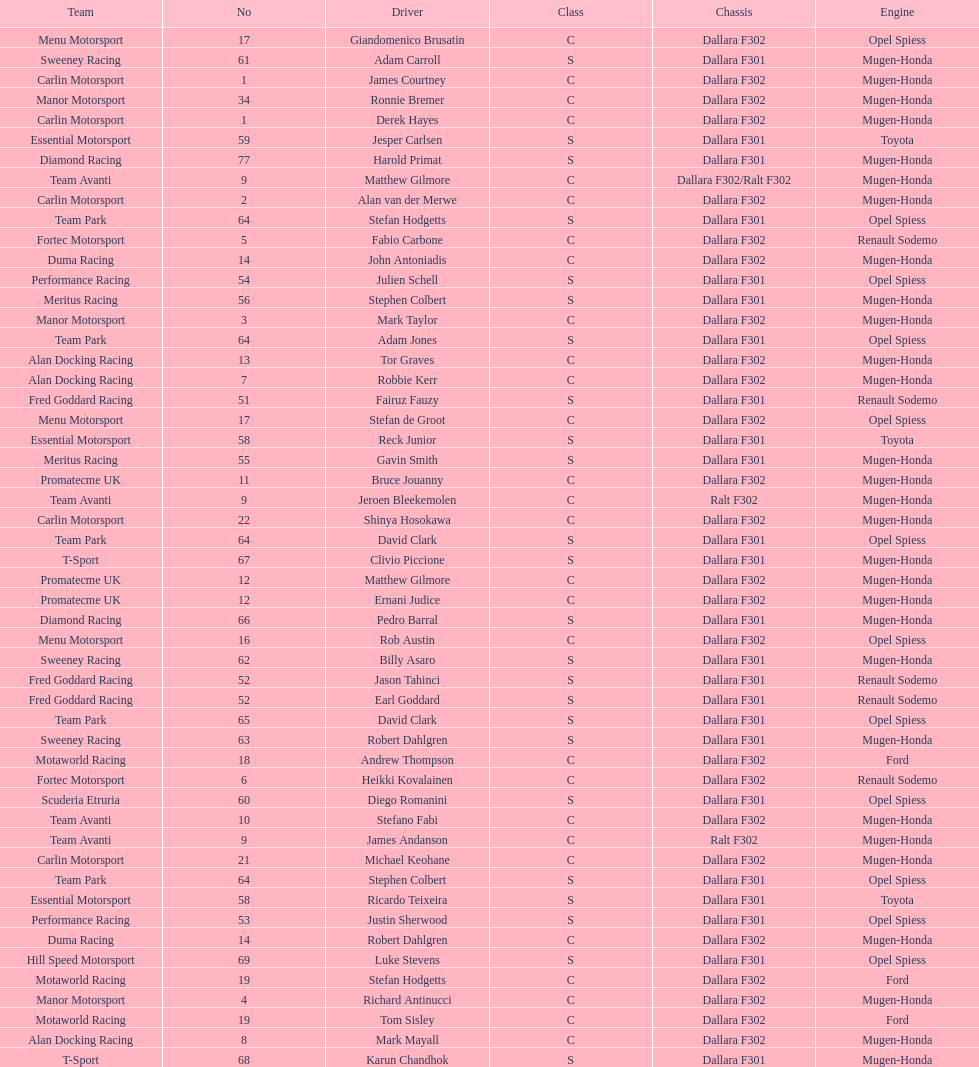How many teams had at least two drivers this season? 17. 